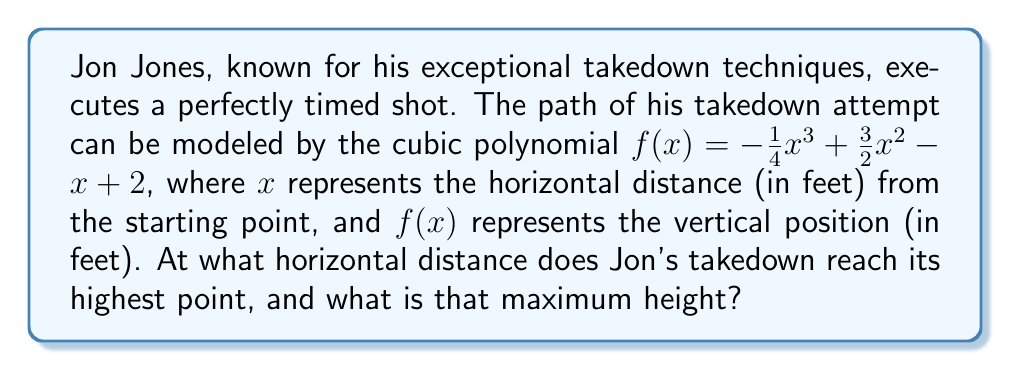Help me with this question. To find the highest point of Jon's takedown attempt, we need to find the maximum of the function $f(x)$. This occurs where the derivative $f'(x)$ is equal to zero.

1) First, let's find the derivative of $f(x)$:
   $$f'(x) = -\frac{3}{4}x^2 + 3x - 1$$

2) Now, set $f'(x) = 0$ and solve for $x$:
   $$-\frac{3}{4}x^2 + 3x - 1 = 0$$

3) This is a quadratic equation. We can solve it using the quadratic formula:
   $$x = \frac{-b \pm \sqrt{b^2 - 4ac}}{2a}$$
   where $a = -\frac{3}{4}$, $b = 3$, and $c = -1$

4) Plugging in these values:
   $$x = \frac{-3 \pm \sqrt{3^2 - 4(-\frac{3}{4})(-1)}}{2(-\frac{3}{4})}$$
   $$= \frac{-3 \pm \sqrt{9 - 3}}{-\frac{3}{2}}$$
   $$= \frac{-3 \pm \sqrt{6}}{-\frac{3}{2}}$$

5) Simplifying:
   $$x = 2 \pm \frac{2\sqrt{6}}{3}$$

6) The smaller value of $x$ will give us the maximum point:
   $$x = 2 - \frac{2\sqrt{6}}{3} \approx 0.367$$

7) To find the maximum height, we plug this $x$ value back into our original function:
   $$f(0.367) = -\frac{1}{4}(0.367)^3 + \frac{3}{2}(0.367)^2 - 0.367 + 2 \approx 2.245$$

Therefore, Jon's takedown reaches its highest point at approximately 0.367 feet horizontally from the starting point, and the maximum height is approximately 2.245 feet.
Answer: Jon's takedown reaches its highest point at approximately 0.367 feet horizontally from the starting point, with a maximum height of approximately 2.245 feet. 